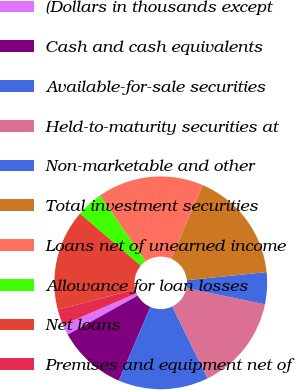Convert chart. <chart><loc_0><loc_0><loc_500><loc_500><pie_chart><fcel>(Dollars in thousands except<fcel>Cash and cash equivalents<fcel>Available-for-sale securities<fcel>Held-to-maturity securities at<fcel>Non-marketable and other<fcel>Total investment securities<fcel>Loans net of unearned income<fcel>Allowance for loan losses<fcel>Net loans<fcel>Premises and equipment net of<nl><fcel>1.61%<fcel>10.48%<fcel>13.71%<fcel>14.52%<fcel>4.84%<fcel>16.94%<fcel>16.13%<fcel>4.03%<fcel>15.32%<fcel>2.42%<nl></chart> 